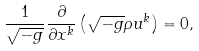Convert formula to latex. <formula><loc_0><loc_0><loc_500><loc_500>\frac { 1 } { \sqrt { - g } } \frac { \partial } { \partial x ^ { k } } \left ( \sqrt { - g } \rho u ^ { k } \right ) = 0 ,</formula> 